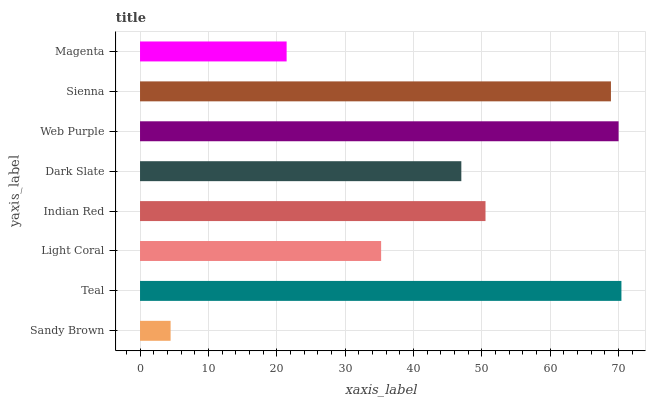Is Sandy Brown the minimum?
Answer yes or no. Yes. Is Teal the maximum?
Answer yes or no. Yes. Is Light Coral the minimum?
Answer yes or no. No. Is Light Coral the maximum?
Answer yes or no. No. Is Teal greater than Light Coral?
Answer yes or no. Yes. Is Light Coral less than Teal?
Answer yes or no. Yes. Is Light Coral greater than Teal?
Answer yes or no. No. Is Teal less than Light Coral?
Answer yes or no. No. Is Indian Red the high median?
Answer yes or no. Yes. Is Dark Slate the low median?
Answer yes or no. Yes. Is Teal the high median?
Answer yes or no. No. Is Sandy Brown the low median?
Answer yes or no. No. 